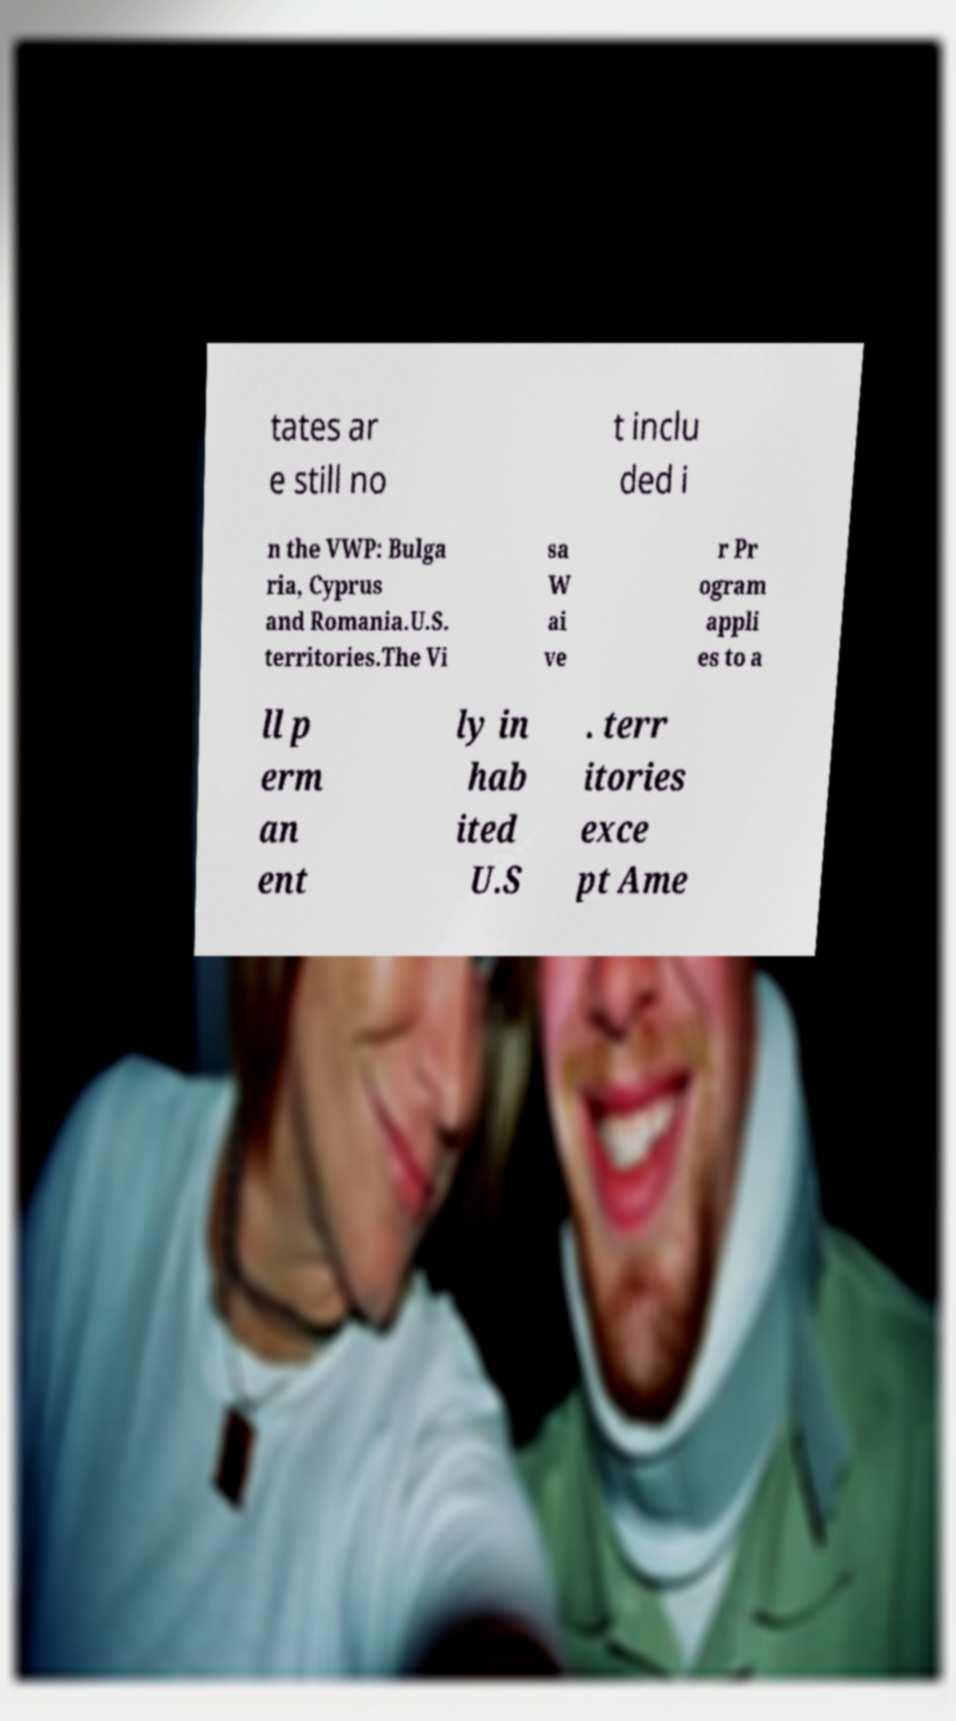Could you assist in decoding the text presented in this image and type it out clearly? tates ar e still no t inclu ded i n the VWP: Bulga ria, Cyprus and Romania.U.S. territories.The Vi sa W ai ve r Pr ogram appli es to a ll p erm an ent ly in hab ited U.S . terr itories exce pt Ame 